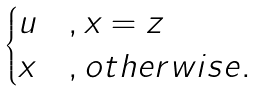<formula> <loc_0><loc_0><loc_500><loc_500>\begin{cases} u & , x = z \\ x & , o t h e r w i s e . \end{cases}</formula> 